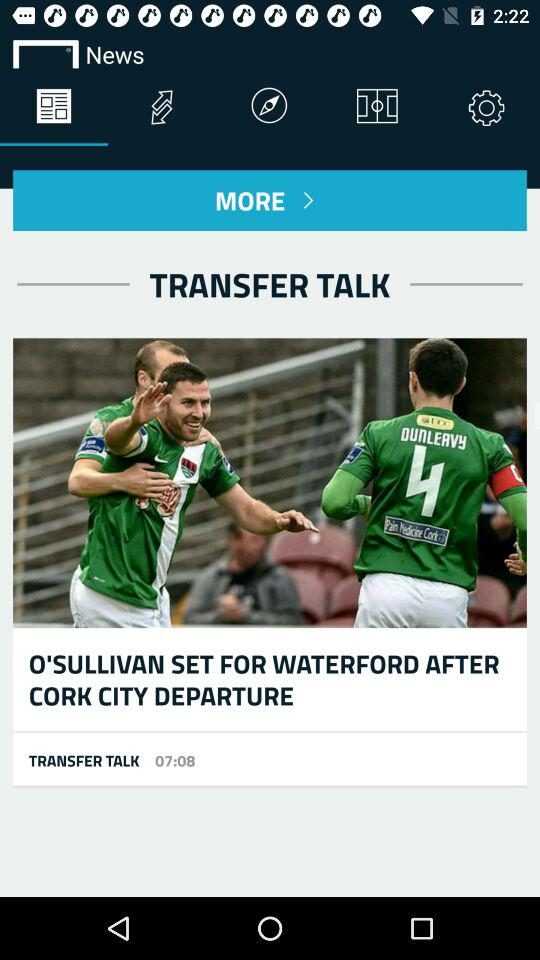What is the shown time? The shown time is 07:08. 